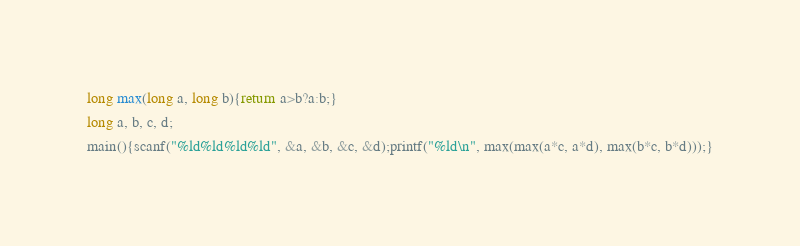Convert code to text. <code><loc_0><loc_0><loc_500><loc_500><_C_>long max(long a, long b){return a>b?a:b;}
long a, b, c, d;
main(){scanf("%ld%ld%ld%ld", &a, &b, &c, &d);printf("%ld\n", max(max(a*c, a*d), max(b*c, b*d)));}</code> 